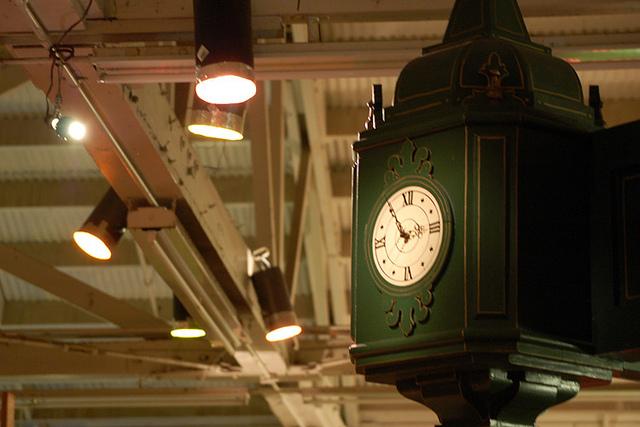What time is shown on the clock?
Concise answer only. 2:55. What color is the clock face?
Be succinct. White. How many lights are turned on in the photo?
Answer briefly. 6. 